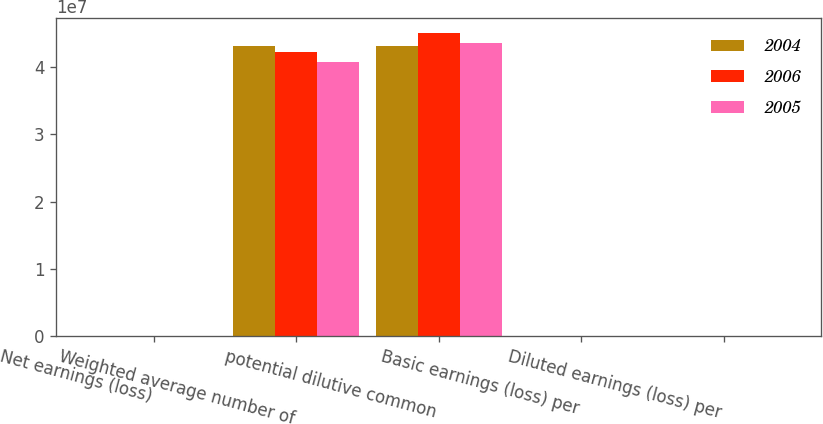<chart> <loc_0><loc_0><loc_500><loc_500><stacked_bar_chart><ecel><fcel>Net earnings (loss)<fcel>Weighted average number of<fcel>potential dilutive common<fcel>Basic earnings (loss) per<fcel>Diluted earnings (loss) per<nl><fcel>2004<fcel>43629<fcel>4.31609e+07<fcel>4.31609e+07<fcel>1.01<fcel>1.01<nl><fcel>2006<fcel>55632<fcel>4.23125e+07<fcel>4.50276e+07<fcel>1.31<fcel>1.24<nl><fcel>2005<fcel>44312<fcel>4.08209e+07<fcel>4.36164e+07<fcel>1.09<fcel>1.02<nl></chart> 